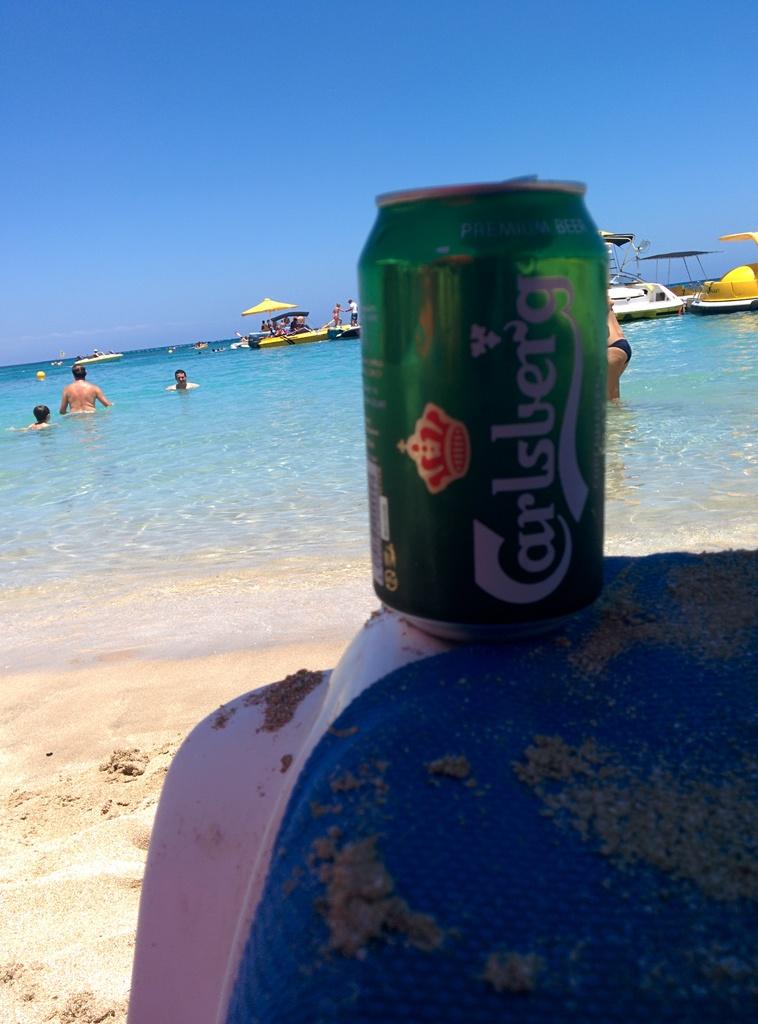What type of drink is this?
Make the answer very short. Carlsberg. What is the brand of this premium beer?
Provide a succinct answer. Carlsberg. 